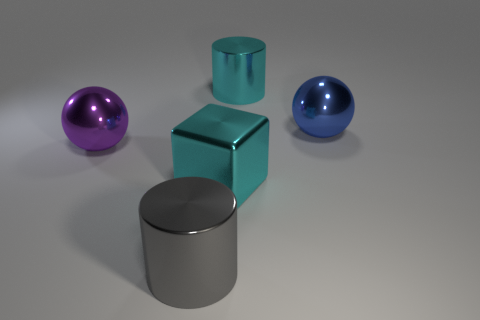What shape is the large gray object that is made of the same material as the big purple thing?
Provide a succinct answer. Cylinder. There is a cyan cube; what number of big cyan metallic cylinders are in front of it?
Ensure brevity in your answer.  0. Are any big yellow rubber balls visible?
Keep it short and to the point. No. The large metal sphere that is to the right of the metallic cylinder behind the big cylinder in front of the cyan metal block is what color?
Provide a succinct answer. Blue. Are there any cyan shiny cylinders on the left side of the large cyan object that is right of the cube?
Keep it short and to the point. No. There is a large cylinder on the right side of the large cyan cube; is it the same color as the big cube that is left of the blue object?
Ensure brevity in your answer.  Yes. How many purple metallic things are the same size as the cyan metal cube?
Provide a succinct answer. 1. Is the size of the metallic object that is behind the blue shiny object the same as the big blue object?
Offer a very short reply. Yes. The gray object is what shape?
Provide a short and direct response. Cylinder. What is the size of the cylinder that is the same color as the large metallic cube?
Make the answer very short. Large. 